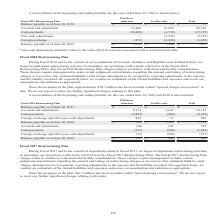According to Opentext Corporation's financial document, What does the table show? reconciliation of the beginning and ending liability for the year ended June 30, 2019. The document states: "A reconciliation of the beginning and ending liability for the year ended June 30, 2019 is shown below...." Also, What are the recent acquisitions of Fiscal 2019? The document shows two values: Catalyst and Liaison. Also, What is the total Balance payable as at June 30, 2019  According to the financial document, 7,107 (in thousands). The relevant text states: "nce payable as at June 30, 2019 $ 1,819 $ 5,288 $ 7,107..." Also, can you calculate: What is the Balance payable as at June 30, 2019 for Workplace reduction expressed as a percentage of total Balance payable? Based on the calculation: 1,819/7,107, the result is 25.59 (percentage). This is based on the information: "nce payable as at June 30, 2019 $ 1,819 $ 5,288 $ 7,107 38) (2,659) Balance payable as at June 30, 2019 $ 1,819 $ 5,288 $ 7,107..." The key data points involved are: 1,819, 7,107. Also, can you calculate: For Accruals and adjustments, What is difference between Workplace reduction & Facility costs? Based on the calculation: 12,460-15,858, the result is -3398 (in thousands). This is based on the information: "une 30, 2018 $ — $ — $ — Accruals and adjustments 12,460 15,858 28,318 Cash payments (10,420) (4,739) (15,159) Non-cash adjustments — (3,393) (3,393) Foreig 2018 $ — $ — $ — Accruals and adjustments 1..." The key data points involved are: 12,460, 15,858. Also, can you calculate: What is the difference between Balance payable as at June 30, 2019 for Workplace reduction & Facility costs? Based on the calculation: 1,819-5,288, the result is -3469 (in thousands). This is based on the information: "59) Balance payable as at June 30, 2019 $ 1,819 $ 5,288 $ 7,107 38) (2,659) Balance payable as at June 30, 2019 $ 1,819 $ 5,288 $ 7,107..." The key data points involved are: 1,819, 5,288. 